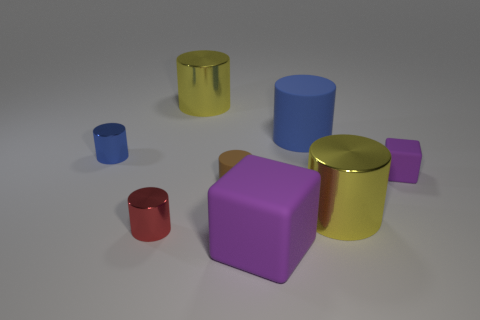Are there any other rubber objects that have the same shape as the brown rubber thing?
Ensure brevity in your answer.  Yes. Do the blue metal thing and the brown matte thing left of the large blue thing have the same size?
Provide a short and direct response. Yes. How many things are big purple objects in front of the large blue thing or purple rubber blocks behind the tiny red cylinder?
Ensure brevity in your answer.  2. Are there more big cylinders that are to the left of the small brown rubber thing than large things?
Offer a terse response. No. How many yellow metal objects have the same size as the blue rubber cylinder?
Your response must be concise. 2. There is a matte object that is behind the tiny blue metal cylinder; is it the same size as the yellow shiny cylinder behind the brown cylinder?
Provide a succinct answer. Yes. There is a shiny cylinder behind the tiny blue thing; what size is it?
Make the answer very short. Large. What size is the matte cylinder in front of the small metal object that is behind the tiny rubber cube?
Keep it short and to the point. Small. There is a purple block that is the same size as the red cylinder; what material is it?
Provide a short and direct response. Rubber. There is a blue metal cylinder; are there any large metallic things right of it?
Give a very brief answer. Yes. 